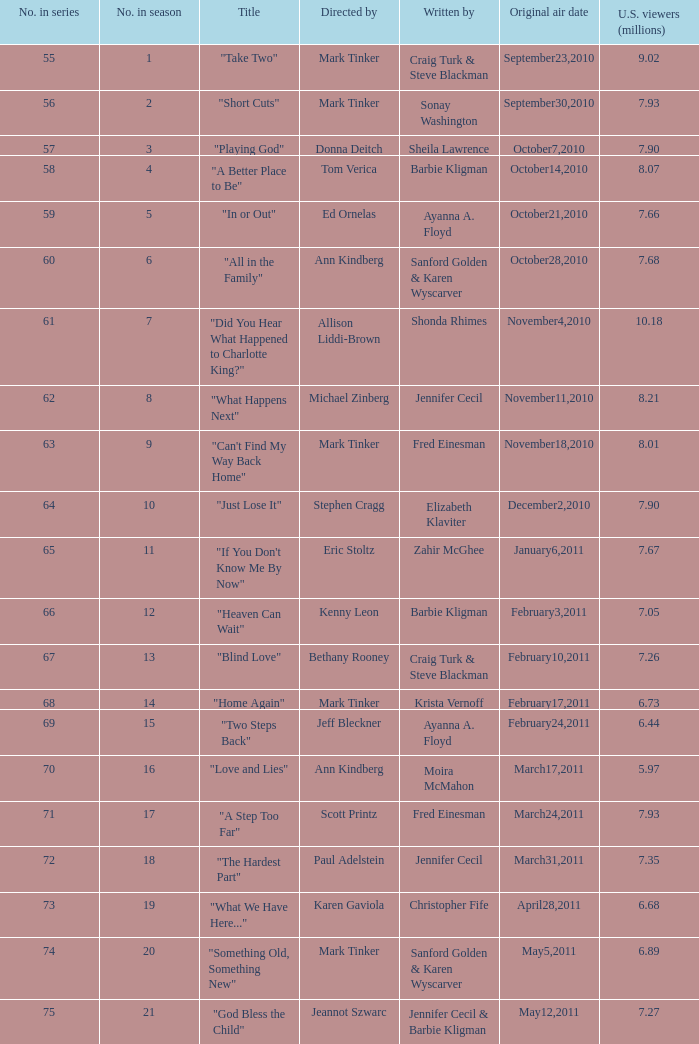What is the earliest numbered episode of the season? 1.0. 